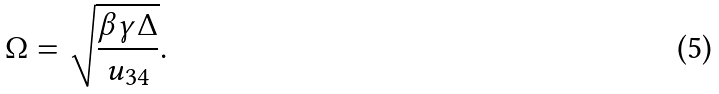<formula> <loc_0><loc_0><loc_500><loc_500>\Omega = \sqrt { \frac { \beta \gamma \Delta } { u _ { 3 4 } } } .</formula> 